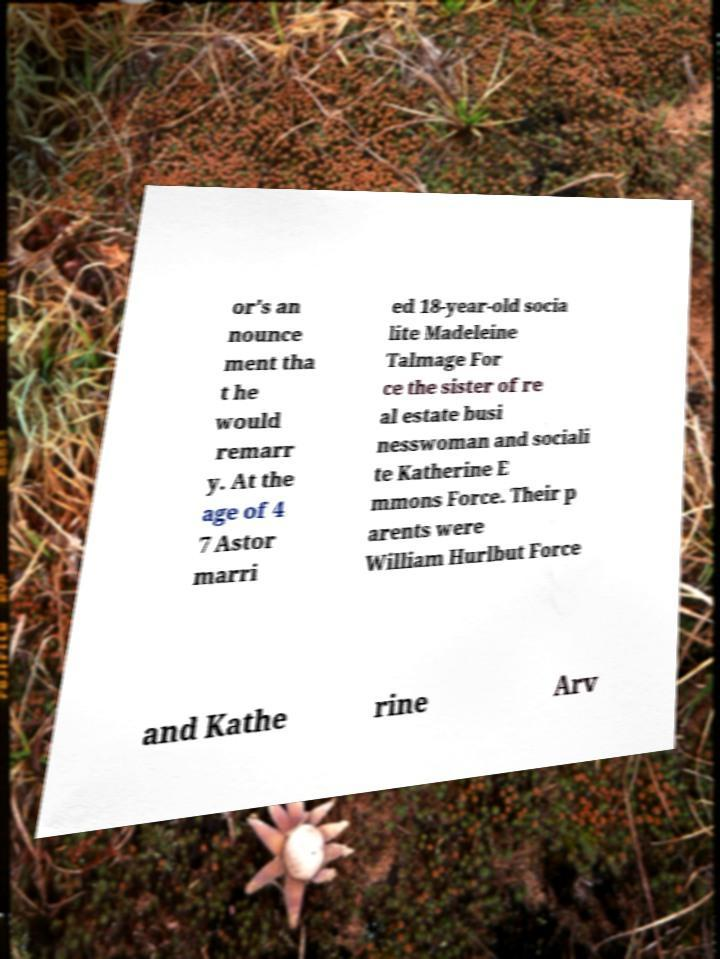Can you accurately transcribe the text from the provided image for me? or's an nounce ment tha t he would remarr y. At the age of 4 7 Astor marri ed 18-year-old socia lite Madeleine Talmage For ce the sister of re al estate busi nesswoman and sociali te Katherine E mmons Force. Their p arents were William Hurlbut Force and Kathe rine Arv 